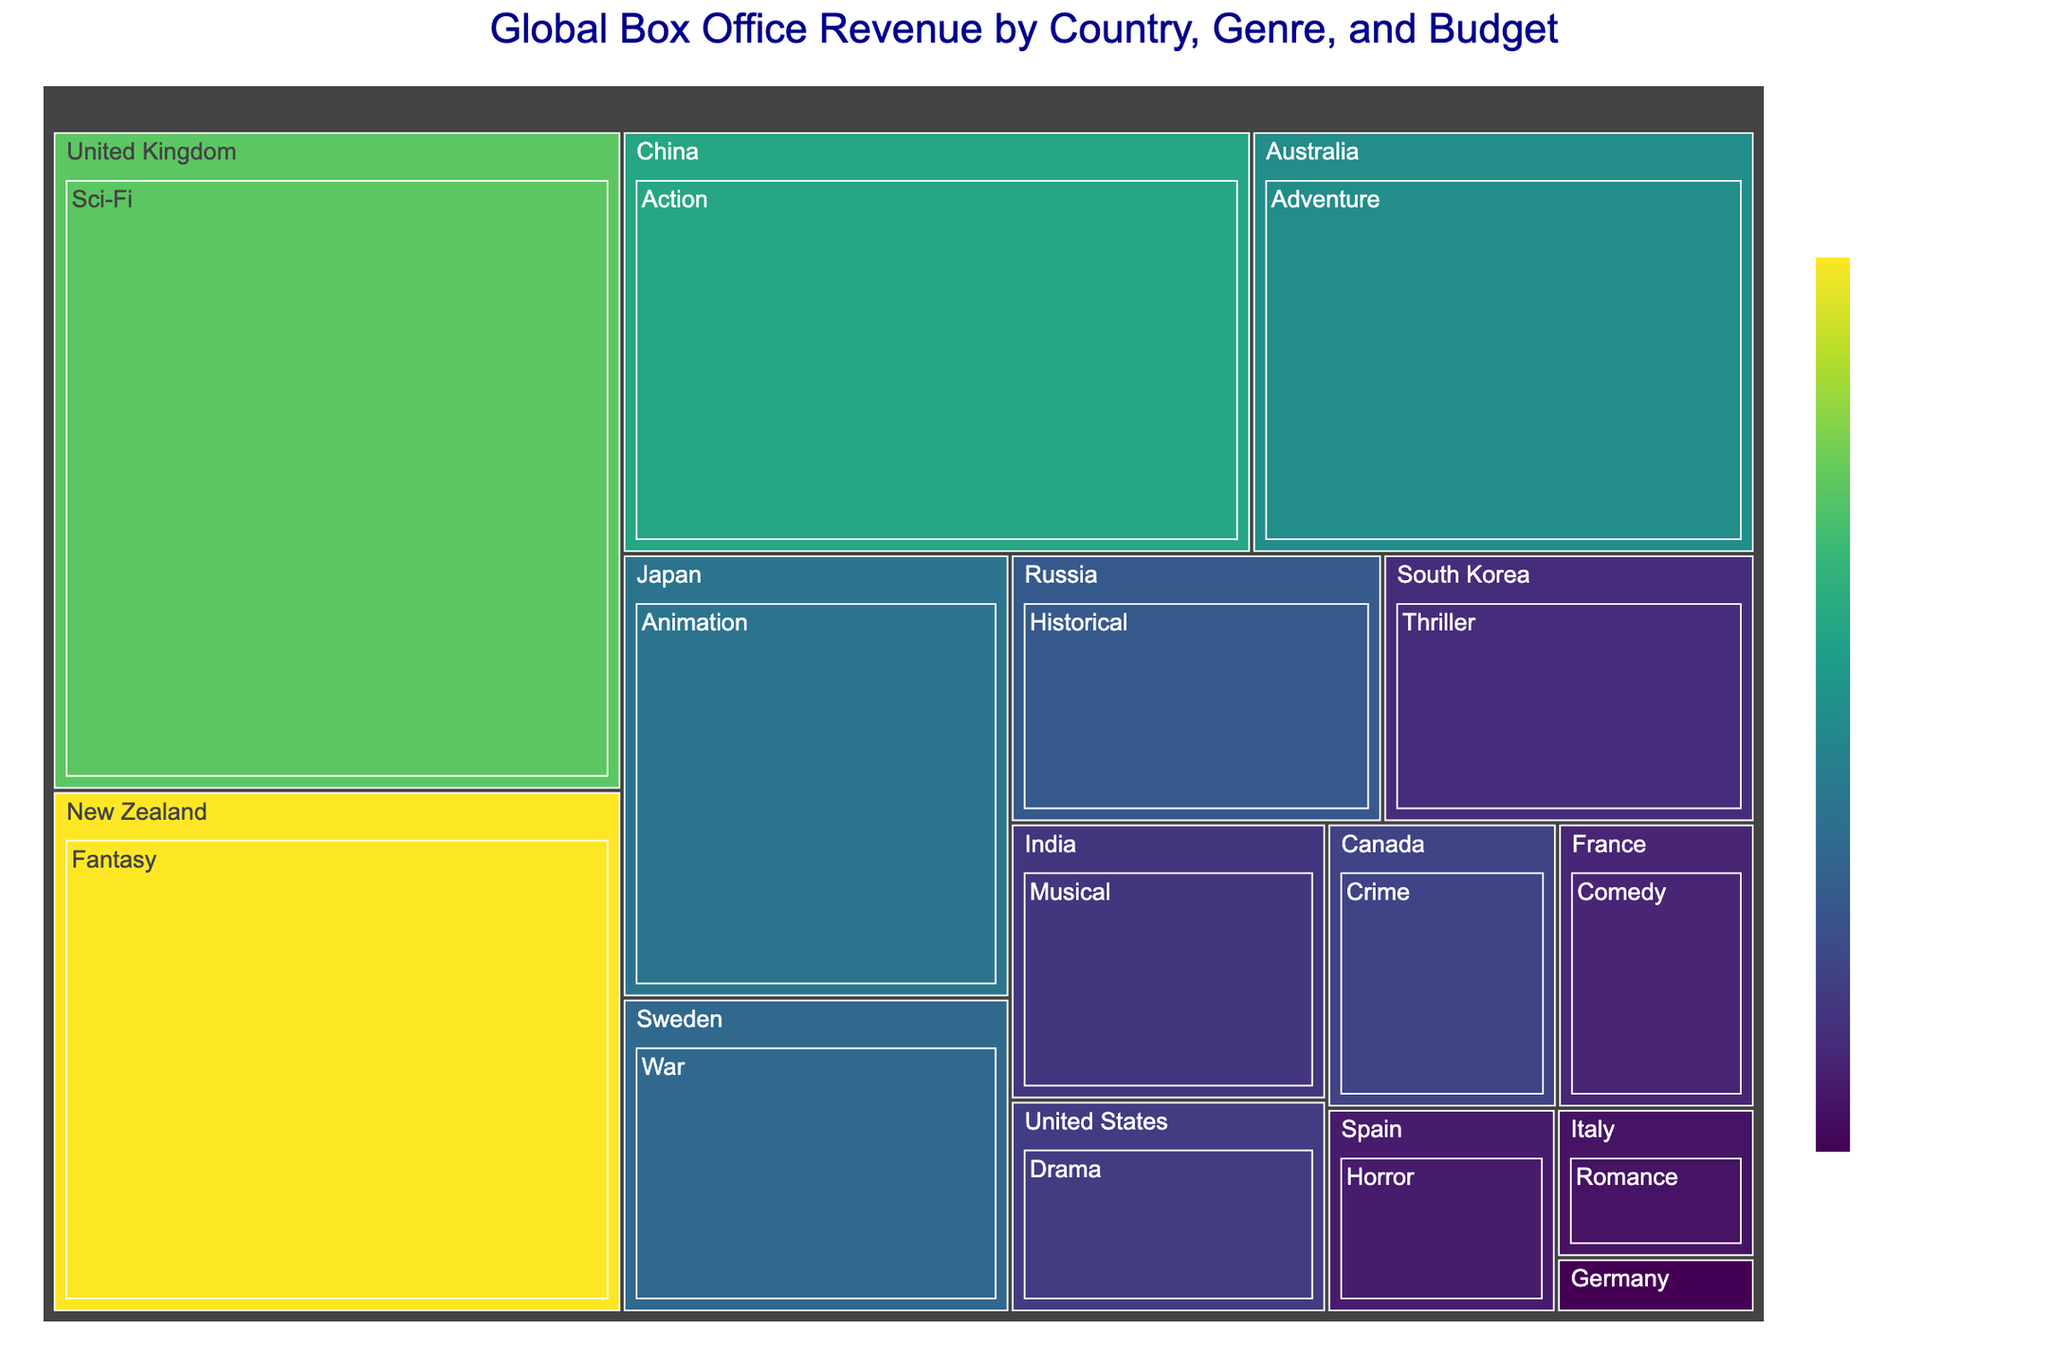What is the title of the figure? The title is prominently displayed at the top center of the figure.
Answer: Global Box Office Revenue by Country, Genre, and Budget Which genre from the United States has the highest revenue? Locate the section representing the United States, and within that, identify the genre with the largest area, which represents the highest revenue.
Answer: Drama What is the budget range shown for the genres in Japan? The colors on the treemap represent the budget range. Identify the different shades within Japan's section to determine the budget range.
Answer: $80,000,000 How much revenue does the Sci-Fi genre contribute from the United Kingdom? Locate the Sci-Fi genre within the United Kingdom section and read its revenue value from the plot.
Answer: $1,200,000,000 Between China and New Zealand, which country produced the genre with the second-highest revenue? Compare the sizes of the treemap sections for each genre in China and New Zealand to find the genre with the second-largest area and note the country.
Answer: New Zealand What is the total revenue of genres from Europe (France, Germany, Italy, Spain)? Calculate the sum of the revenue values from France, Germany, Italy, and Spain sections.
Answer: $495,000,000 Is the budget for the Fantasy genre in New Zealand larger or smaller than the budget for the Sci-Fi genre in the United Kingdom? Compare the color shades representing the budget of Fantasy in New Zealand with Sci-Fi in the United Kingdom using the color legend.
Answer: Smaller Which genre has the lowest budget among all represented countries? Identify the genre with the darkest shade in the treemap, indicating the lowest budget.
Answer: Documentary (Germany) Which two countries have genres with a budget of $35,000,000? Identify the sections in the treemap with shades of color corresponding to a $35,000,000 budget and note the countries.
Answer: India and France Among the genres listed for historical and war films, which genre has a higher revenue? Compare the area allocated to Historical (Russia) and War (Sweden) genres in the treemap.
Answer: War 